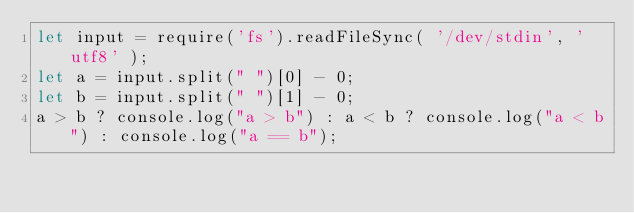Convert code to text. <code><loc_0><loc_0><loc_500><loc_500><_JavaScript_>let input = require('fs').readFileSync( '/dev/stdin', 'utf8' );
let a = input.split(" ")[0] - 0;
let b = input.split(" ")[1] - 0;
a > b ? console.log("a > b") : a < b ? console.log("a < b") : console.log("a == b");
</code> 